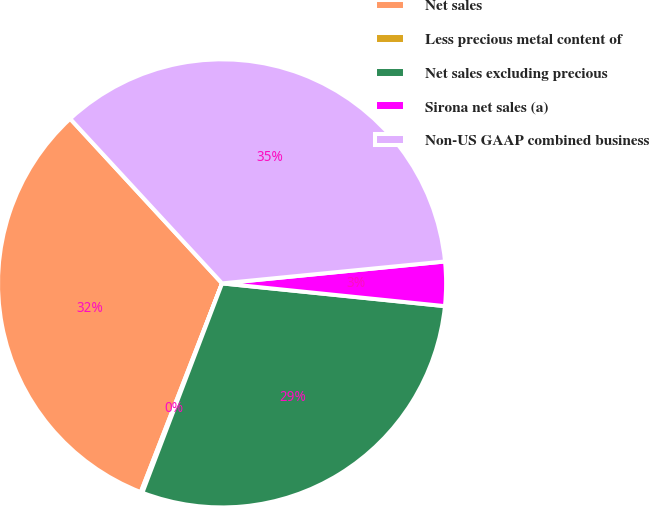<chart> <loc_0><loc_0><loc_500><loc_500><pie_chart><fcel>Net sales<fcel>Less precious metal content of<fcel>Net sales excluding precious<fcel>Sirona net sales (a)<fcel>Non-US GAAP combined business<nl><fcel>32.23%<fcel>0.12%<fcel>29.17%<fcel>3.18%<fcel>35.3%<nl></chart> 